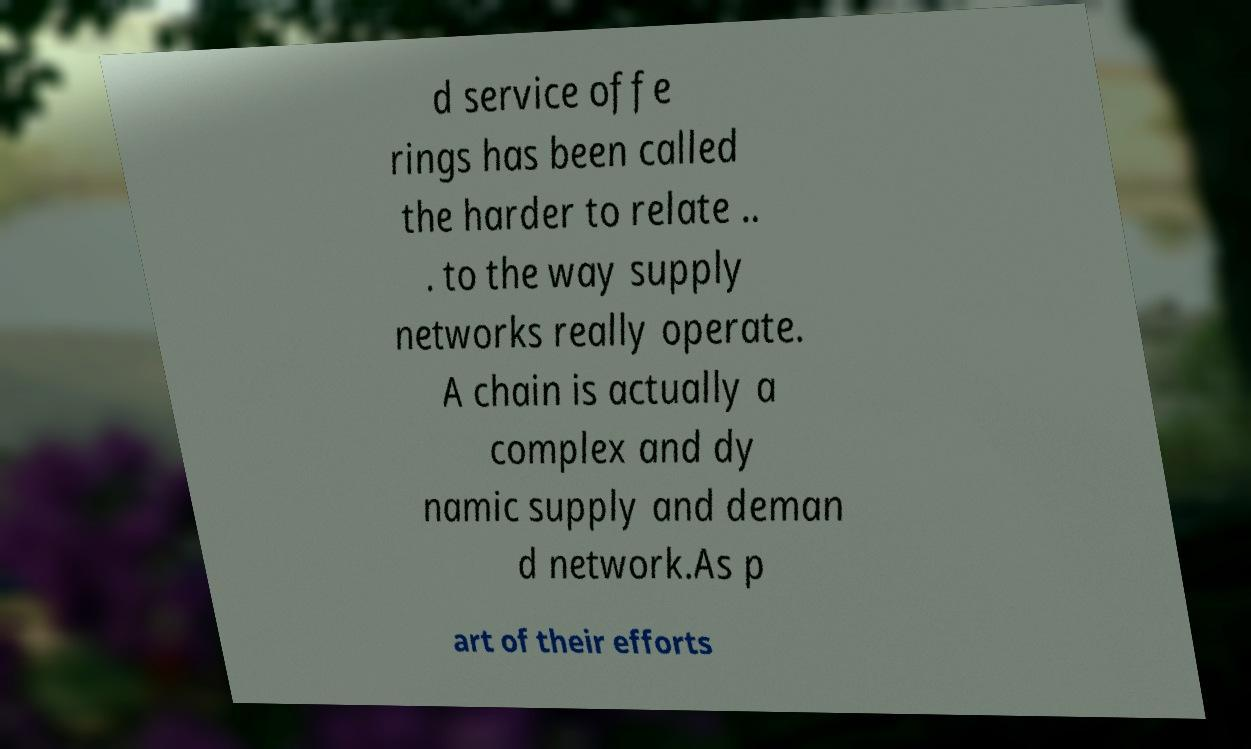I need the written content from this picture converted into text. Can you do that? d service offe rings has been called the harder to relate .. . to the way supply networks really operate. A chain is actually a complex and dy namic supply and deman d network.As p art of their efforts 